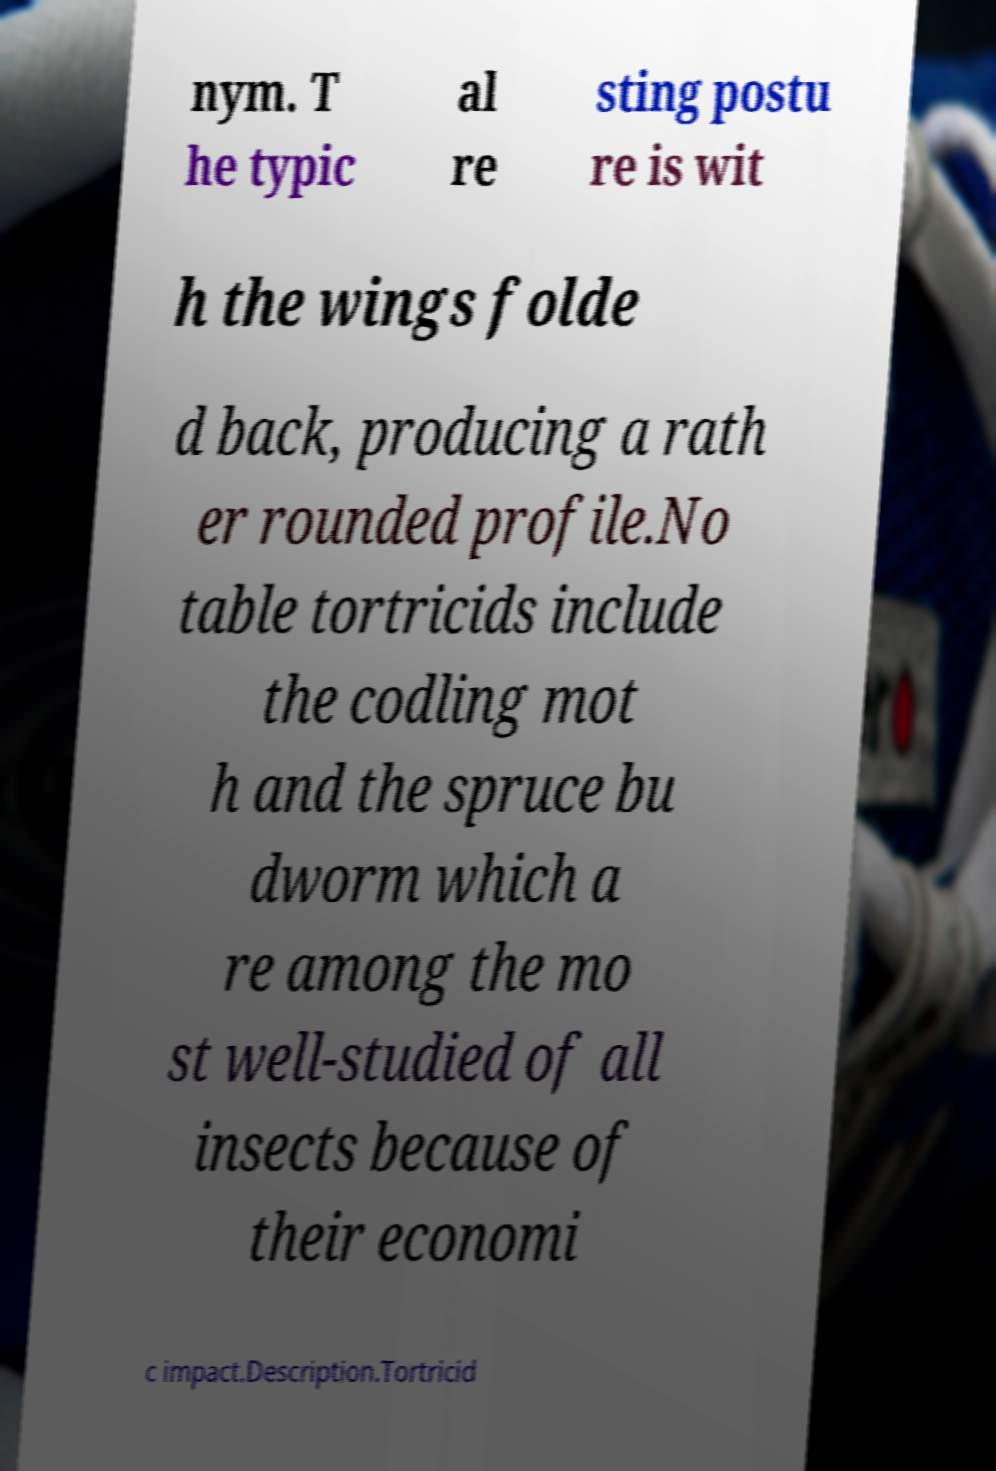Can you read and provide the text displayed in the image?This photo seems to have some interesting text. Can you extract and type it out for me? nym. T he typic al re sting postu re is wit h the wings folde d back, producing a rath er rounded profile.No table tortricids include the codling mot h and the spruce bu dworm which a re among the mo st well-studied of all insects because of their economi c impact.Description.Tortricid 